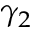Convert formula to latex. <formula><loc_0><loc_0><loc_500><loc_500>\gamma _ { 2 }</formula> 